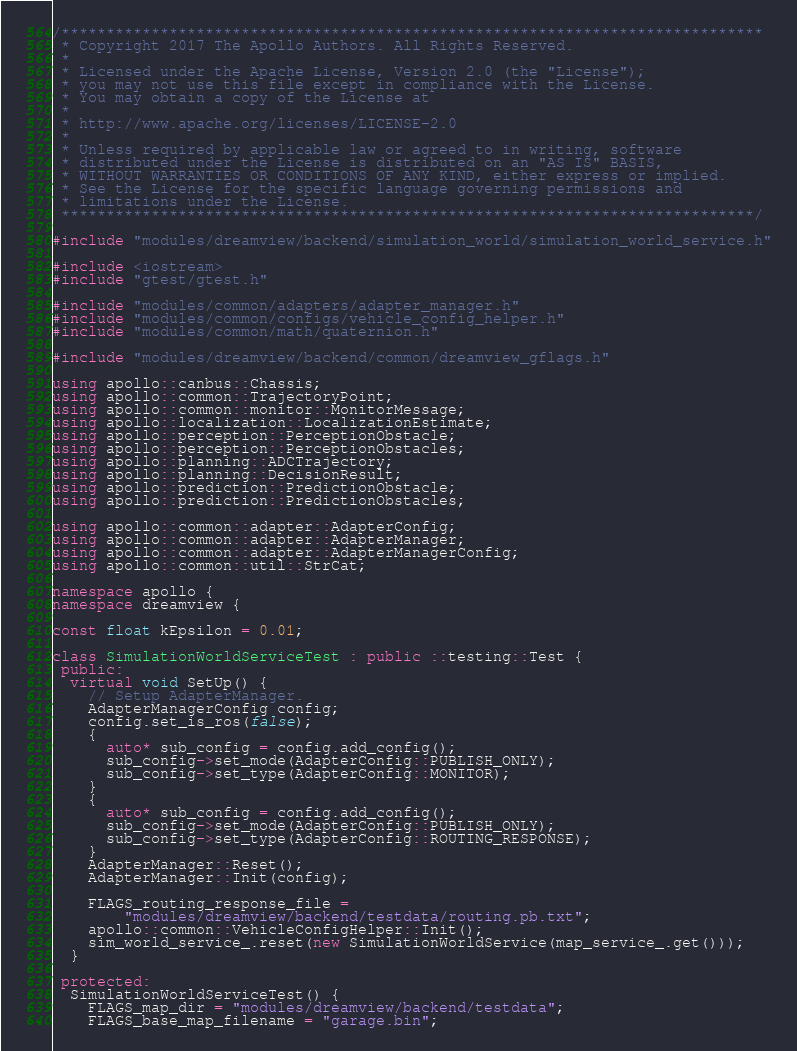Convert code to text. <code><loc_0><loc_0><loc_500><loc_500><_C++_>/******************************************************************************
 * Copyright 2017 The Apollo Authors. All Rights Reserved.
 *
 * Licensed under the Apache License, Version 2.0 (the "License");
 * you may not use this file except in compliance with the License.
 * You may obtain a copy of the License at
 *
 * http://www.apache.org/licenses/LICENSE-2.0
 *
 * Unless required by applicable law or agreed to in writing, software
 * distributed under the License is distributed on an "AS IS" BASIS,
 * WITHOUT WARRANTIES OR CONDITIONS OF ANY KIND, either express or implied.
 * See the License for the specific language governing permissions and
 * limitations under the License.
 *****************************************************************************/

#include "modules/dreamview/backend/simulation_world/simulation_world_service.h"

#include <iostream>
#include "gtest/gtest.h"

#include "modules/common/adapters/adapter_manager.h"
#include "modules/common/configs/vehicle_config_helper.h"
#include "modules/common/math/quaternion.h"

#include "modules/dreamview/backend/common/dreamview_gflags.h"

using apollo::canbus::Chassis;
using apollo::common::TrajectoryPoint;
using apollo::common::monitor::MonitorMessage;
using apollo::localization::LocalizationEstimate;
using apollo::perception::PerceptionObstacle;
using apollo::perception::PerceptionObstacles;
using apollo::planning::ADCTrajectory;
using apollo::planning::DecisionResult;
using apollo::prediction::PredictionObstacle;
using apollo::prediction::PredictionObstacles;

using apollo::common::adapter::AdapterConfig;
using apollo::common::adapter::AdapterManager;
using apollo::common::adapter::AdapterManagerConfig;
using apollo::common::util::StrCat;

namespace apollo {
namespace dreamview {

const float kEpsilon = 0.01;

class SimulationWorldServiceTest : public ::testing::Test {
 public:
  virtual void SetUp() {
    // Setup AdapterManager.
    AdapterManagerConfig config;
    config.set_is_ros(false);
    {
      auto* sub_config = config.add_config();
      sub_config->set_mode(AdapterConfig::PUBLISH_ONLY);
      sub_config->set_type(AdapterConfig::MONITOR);
    }
    {
      auto* sub_config = config.add_config();
      sub_config->set_mode(AdapterConfig::PUBLISH_ONLY);
      sub_config->set_type(AdapterConfig::ROUTING_RESPONSE);
    }
    AdapterManager::Reset();
    AdapterManager::Init(config);

    FLAGS_routing_response_file =
        "modules/dreamview/backend/testdata/routing.pb.txt";
    apollo::common::VehicleConfigHelper::Init();
    sim_world_service_.reset(new SimulationWorldService(map_service_.get()));
  }

 protected:
  SimulationWorldServiceTest() {
    FLAGS_map_dir = "modules/dreamview/backend/testdata";
    FLAGS_base_map_filename = "garage.bin";</code> 